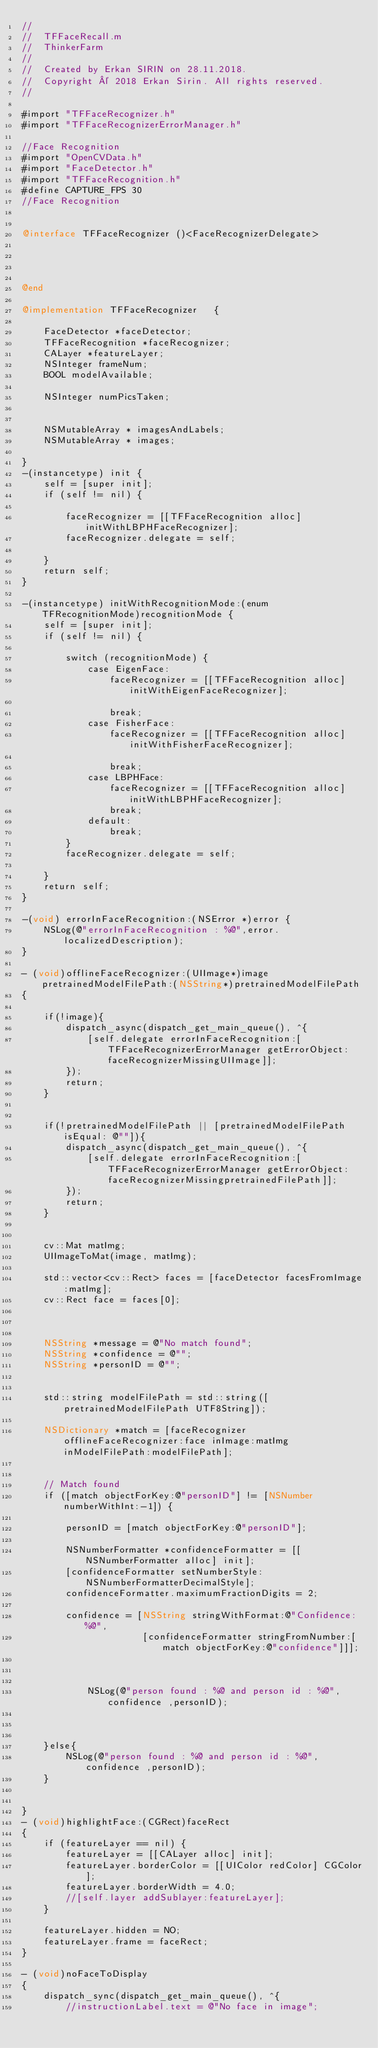Convert code to text. <code><loc_0><loc_0><loc_500><loc_500><_ObjectiveC_>//
//  TFFaceRecall.m
//  ThinkerFarm
//
//  Created by Erkan SIRIN on 28.11.2018.
//  Copyright © 2018 Erkan Sirin. All rights reserved.
//

#import "TFFaceRecognizer.h"
#import "TFFaceRecognizerErrorManager.h"

//Face Recognition
#import "OpenCVData.h"
#import "FaceDetector.h"
#import "TFFaceRecognition.h"
#define CAPTURE_FPS 30
//Face Recognition


@interface TFFaceRecognizer ()<FaceRecognizerDelegate>




@end

@implementation TFFaceRecognizer   {
    
    FaceDetector *faceDetector;
    TFFaceRecognition *faceRecognizer;
    CALayer *featureLayer;
    NSInteger frameNum;
    BOOL modelAvailable;

    NSInteger numPicsTaken;


    NSMutableArray * imagesAndLabels;
    NSMutableArray * images;
    
}
-(instancetype) init {
    self = [super init];
    if (self != nil) {

        faceRecognizer = [[TFFaceRecognition alloc] initWithLBPHFaceRecognizer];
        faceRecognizer.delegate = self;

    }
    return self;
}

-(instancetype) initWithRecognitionMode:(enum TFRecognitionMode)recognitionMode {
    self = [super init];
    if (self != nil) {
        
        switch (recognitionMode) {
            case EigenFace:
                faceRecognizer = [[TFFaceRecognition alloc] initWithEigenFaceRecognizer];
                
                break;
            case FisherFace:
                faceRecognizer = [[TFFaceRecognition alloc] initWithFisherFaceRecognizer];
                
                break;
            case LBPHFace:
                faceRecognizer = [[TFFaceRecognition alloc] initWithLBPHFaceRecognizer];
                break;
            default:
                break;
        }
        faceRecognizer.delegate = self;

    }
    return self;
}

-(void) errorInFaceRecognition:(NSError *)error {
    NSLog(@"errorInFaceRecognition : %@",error.localizedDescription);
}

- (void)offlineFaceRecognizer:(UIImage*)image pretrainedModelFilePath:(NSString*)pretrainedModelFilePath
{
    
    if(!image){
        dispatch_async(dispatch_get_main_queue(), ^{
            [self.delegate errorInFaceRecognition:[TFFaceRecognizerErrorManager getErrorObject:faceRecognizerMissingUIImage]];
        });
        return;
    }
    
    
    if(!pretrainedModelFilePath || [pretrainedModelFilePath  isEqual: @""]){
        dispatch_async(dispatch_get_main_queue(), ^{
            [self.delegate errorInFaceRecognition:[TFFaceRecognizerErrorManager getErrorObject:faceRecognizerMissingpretrainedFilePath]];
        });
        return;
    }
    
    
    cv::Mat matImg;
    UIImageToMat(image, matImg);
    
    std::vector<cv::Rect> faces = [faceDetector facesFromImage:matImg];
    cv::Rect face = faces[0];
    
    
 
    NSString *message = @"No match found";
    NSString *confidence = @"";
    NSString *personID = @"";
    
   
    std::string modelFilePath = std::string([pretrainedModelFilePath UTF8String]);
    
    NSDictionary *match = [faceRecognizer offlineFaceRecognizer:face inImage:matImg inModelFilePath:modelFilePath];
    
    
    // Match found
    if ([match objectForKey:@"personID"] != [NSNumber numberWithInt:-1]) {
        
        personID = [match objectForKey:@"personID"];
       
        NSNumberFormatter *confidenceFormatter = [[NSNumberFormatter alloc] init];
        [confidenceFormatter setNumberStyle:NSNumberFormatterDecimalStyle];
        confidenceFormatter.maximumFractionDigits = 2;
        
        confidence = [NSString stringWithFormat:@"Confidence: %@",
                      [confidenceFormatter stringFromNumber:[match objectForKey:@"confidence"]]];
        
        
  
            NSLog(@"person found : %@ and person id : %@",confidence ,personID);
            
   
        
    }else{
        NSLog(@"person found : %@ and person id : %@",confidence ,personID);
    }
    

}
- (void)highlightFace:(CGRect)faceRect
{
    if (featureLayer == nil) {
        featureLayer = [[CALayer alloc] init];
        featureLayer.borderColor = [[UIColor redColor] CGColor];
        featureLayer.borderWidth = 4.0;
        //[self.layer addSublayer:featureLayer];
    }
    
    featureLayer.hidden = NO;
    featureLayer.frame = faceRect;
}

- (void)noFaceToDisplay
{
    dispatch_sync(dispatch_get_main_queue(), ^{
        //instructionLabel.text = @"No face in image";</code> 